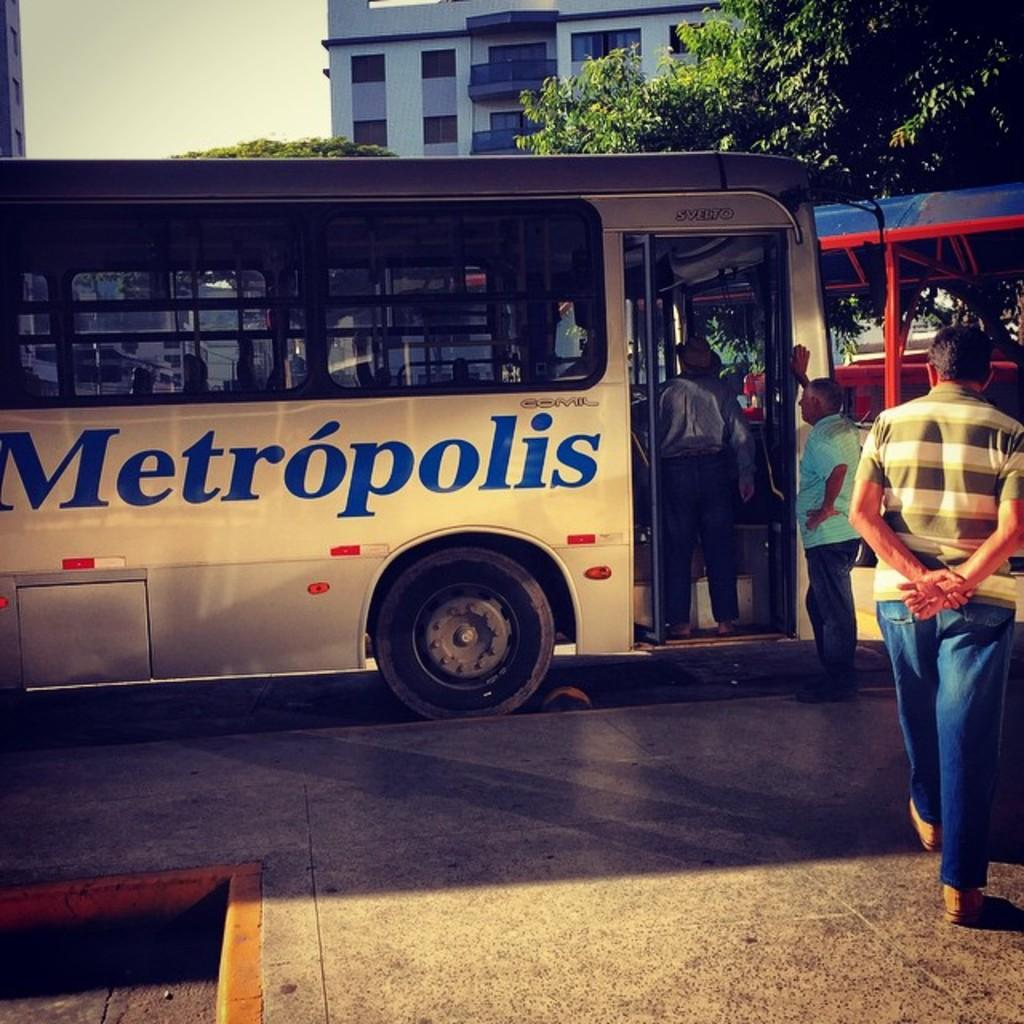What is the main subject of the image? The main subject of the image is a bus. Are there any other elements in the image besides the bus? Yes, there are people, buildings, trees, and the sky visible in the image. Can you describe the setting of the image? The image appears to be set in an urban environment, with buildings and trees in the background. What is visible at the top of the image? The sky is visible at the top of the image. What type of religious print can be seen hanging in the bus? There is no religious print visible in the image; it features a bus in an urban environment. What type of wine is being served to the people in the image? There is no wine present in the image; it features a bus with people, buildings, trees, and the sky. 